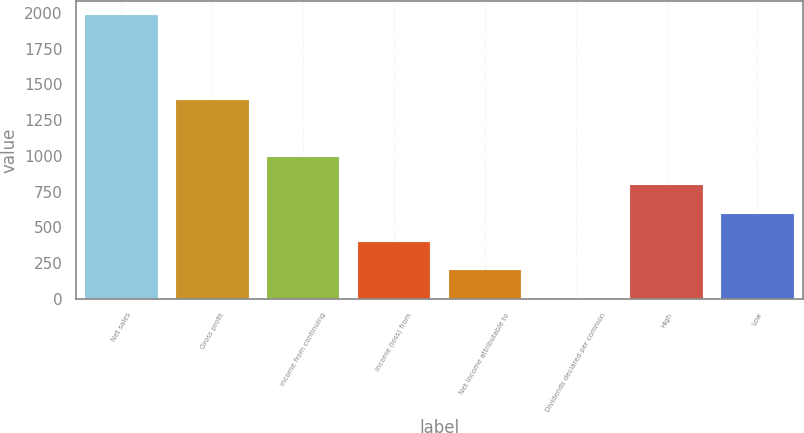Convert chart to OTSL. <chart><loc_0><loc_0><loc_500><loc_500><bar_chart><fcel>Net sales<fcel>Gross profit<fcel>Income from continuing<fcel>Income (loss) from<fcel>Net income attributable to<fcel>Dividends declared per common<fcel>High<fcel>Low<nl><fcel>1981.2<fcel>1386.9<fcel>990.7<fcel>396.4<fcel>198.3<fcel>0.2<fcel>792.6<fcel>594.5<nl></chart> 